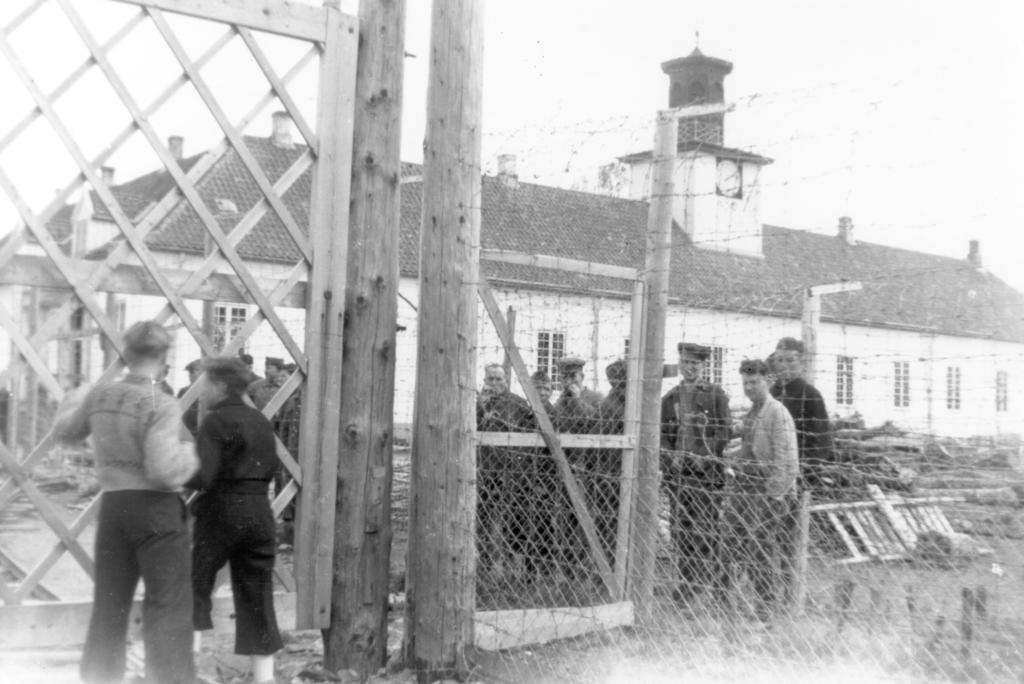Who or what can be seen in the image? There are people in the image. What is the purpose of the fence in the image? The fence is a structural element in the image, but its specific purpose cannot be determined from the facts provided. What type of structure is visible in the image? There is a building in the image. What part of the natural environment is visible in the image? The sky is visible in the image. What is the color scheme of the image? The image is black and white in color. How many pins are holding the base of the building in the image? There is no mention of a base or pins in the image, so this question cannot be answered definitively. 